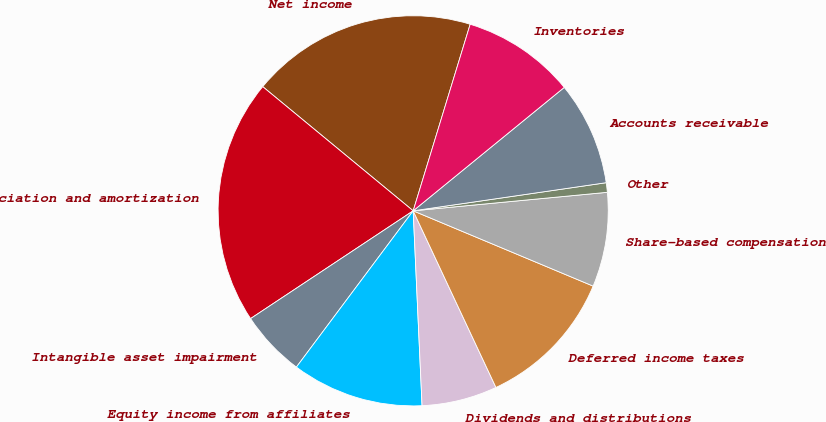Convert chart to OTSL. <chart><loc_0><loc_0><loc_500><loc_500><pie_chart><fcel>Net income<fcel>Depreciation and amortization<fcel>Intangible asset impairment<fcel>Equity income from affiliates<fcel>Dividends and distributions<fcel>Deferred income taxes<fcel>Share-based compensation<fcel>Other<fcel>Accounts receivable<fcel>Inventories<nl><fcel>18.74%<fcel>20.3%<fcel>5.47%<fcel>10.94%<fcel>6.25%<fcel>11.72%<fcel>7.82%<fcel>0.79%<fcel>8.6%<fcel>9.38%<nl></chart> 